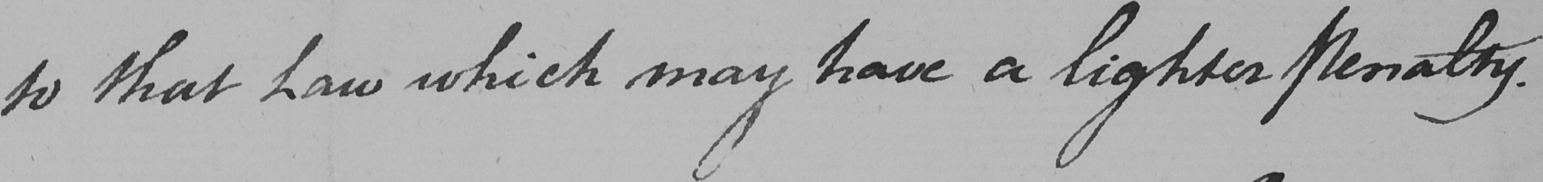Please transcribe the handwritten text in this image. to that Law which may have a lighter penalty . 